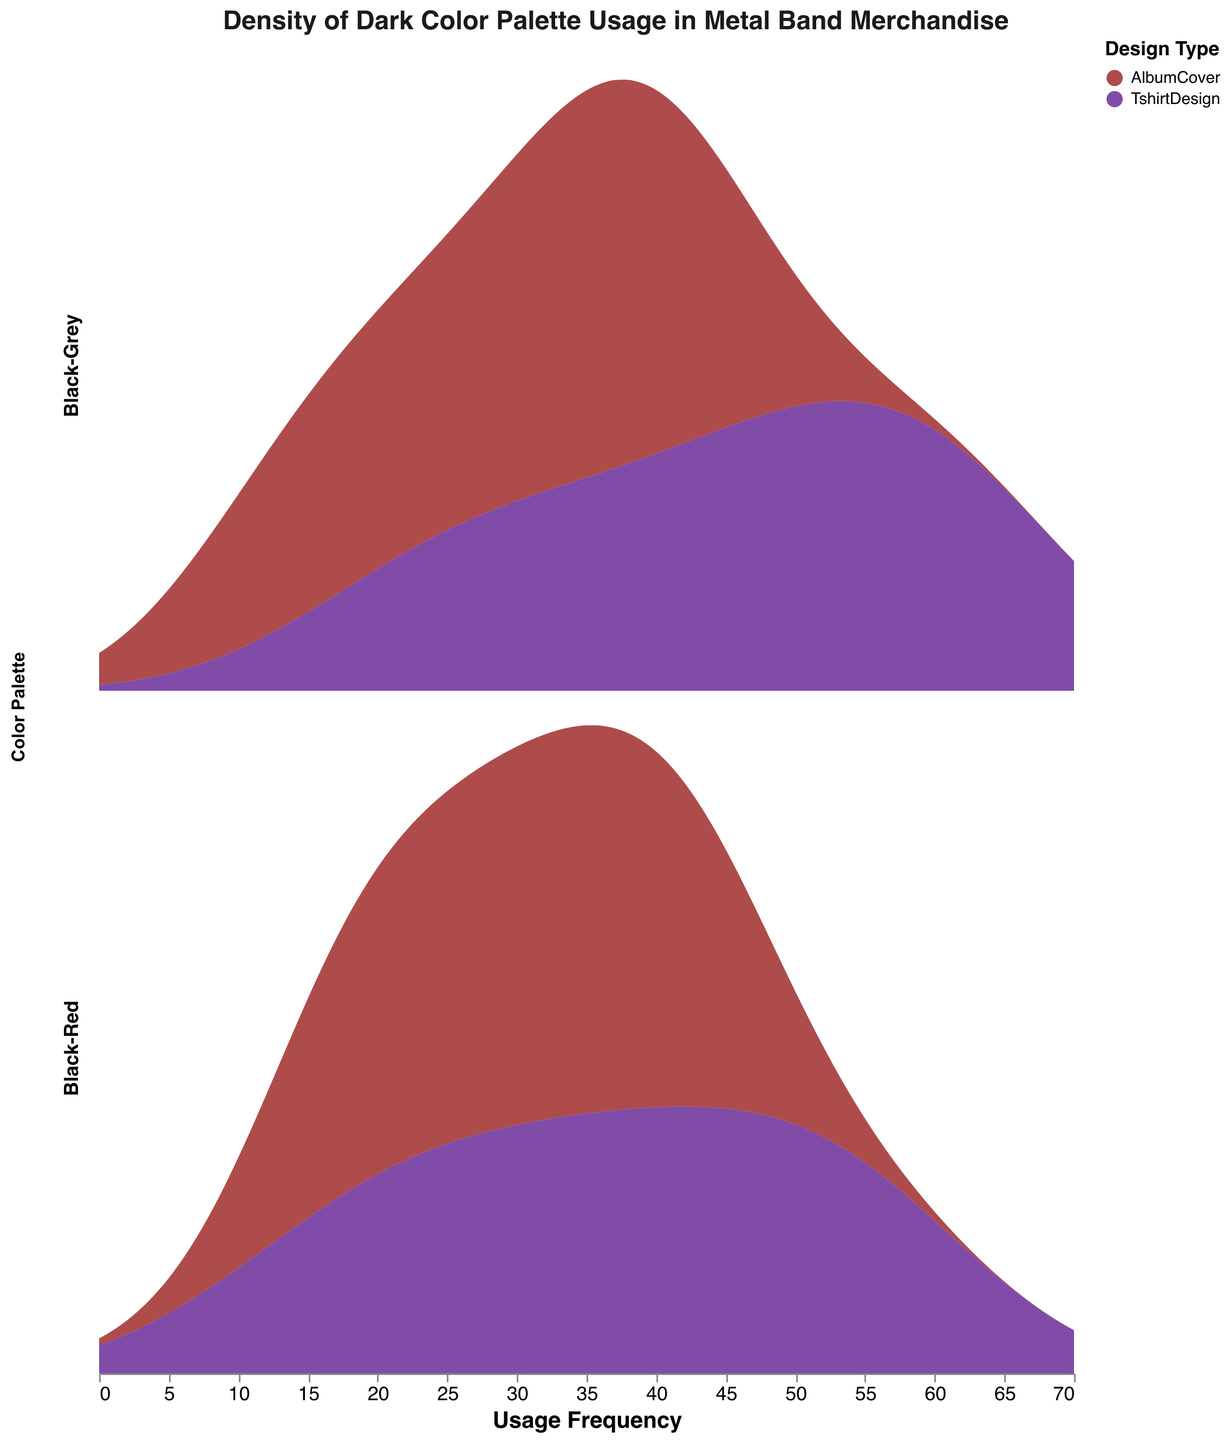How many design types are shown in the plot? The figure shows two distinct design types represented by colors. One is AlbumCover (dark red) and the other is TshirtDesign (indigo).
Answer: 2 What are the titles of the x-axis and y-axis? The x-axis is titled "Usage Frequency." The y-axis does not have a title as indicated by the "axis": null setting for the y-field.
Answer: Usage Frequency, None What is the overall trend in usage frequency of the Black-Grey palette for TshirtDesigns? Observing the density plot for TshirtDesign under the Black-Grey palette shows a consistent upward usage trend from 2010 to 2022 with increasing usage frequency — peaking towards the higher end of the frequency scale.
Answer: Increasing Which color palette and design type combination has the highest density at the highest usage frequency? The Black-Grey color palette used in TshirtDesigns reaches the highest density at the upper end of the usage frequency spectrum, near 65.
Answer: Black-Grey TshirtDesign Compare the peaks in usage frequency density for AlbumCover designs using Black-Red and Black-Grey palettes. Which has a higher peak? The density plot shows that AlbumCover designs using the Black-Grey palette have slightly higher peaks compared to those using the Black-Red palette. The peaks of Black-Grey are more prominent at intermediate usage frequencies.
Answer: Black-Grey What specific feature distinguishes the design types visually in the plot? The two design types are distinguished by their colors: AlbumCover is shown in dark red while TshirtDesign is shown in indigo.
Answer: Colors What is the range of the x-axis usage frequency in the plot? The x-axis titled "Usage Frequency" ranges from 0 to 70, as indicated by the plot's axis configuration.
Answer: 0-70 Compare the density distribution of the Black-Red palette in AlbumCover and TshirtDesign at 30 usage frequency. At 30 usage frequency, the density of the Black-Red palette is higher in TshirtDesign compared to AlbumCover, indicating a greater frequency of that use for Tshirts.
Answer: Higher in TshirtDesign What year shows the most frequent use of the Black-Grey palette for TshirtDesign? The plot indicates ascending trends and the highest density range towards 2022, showing that the most frequent use of the Black-Grey palette for TshirtDesign is in the year 2022.
Answer: 2022 